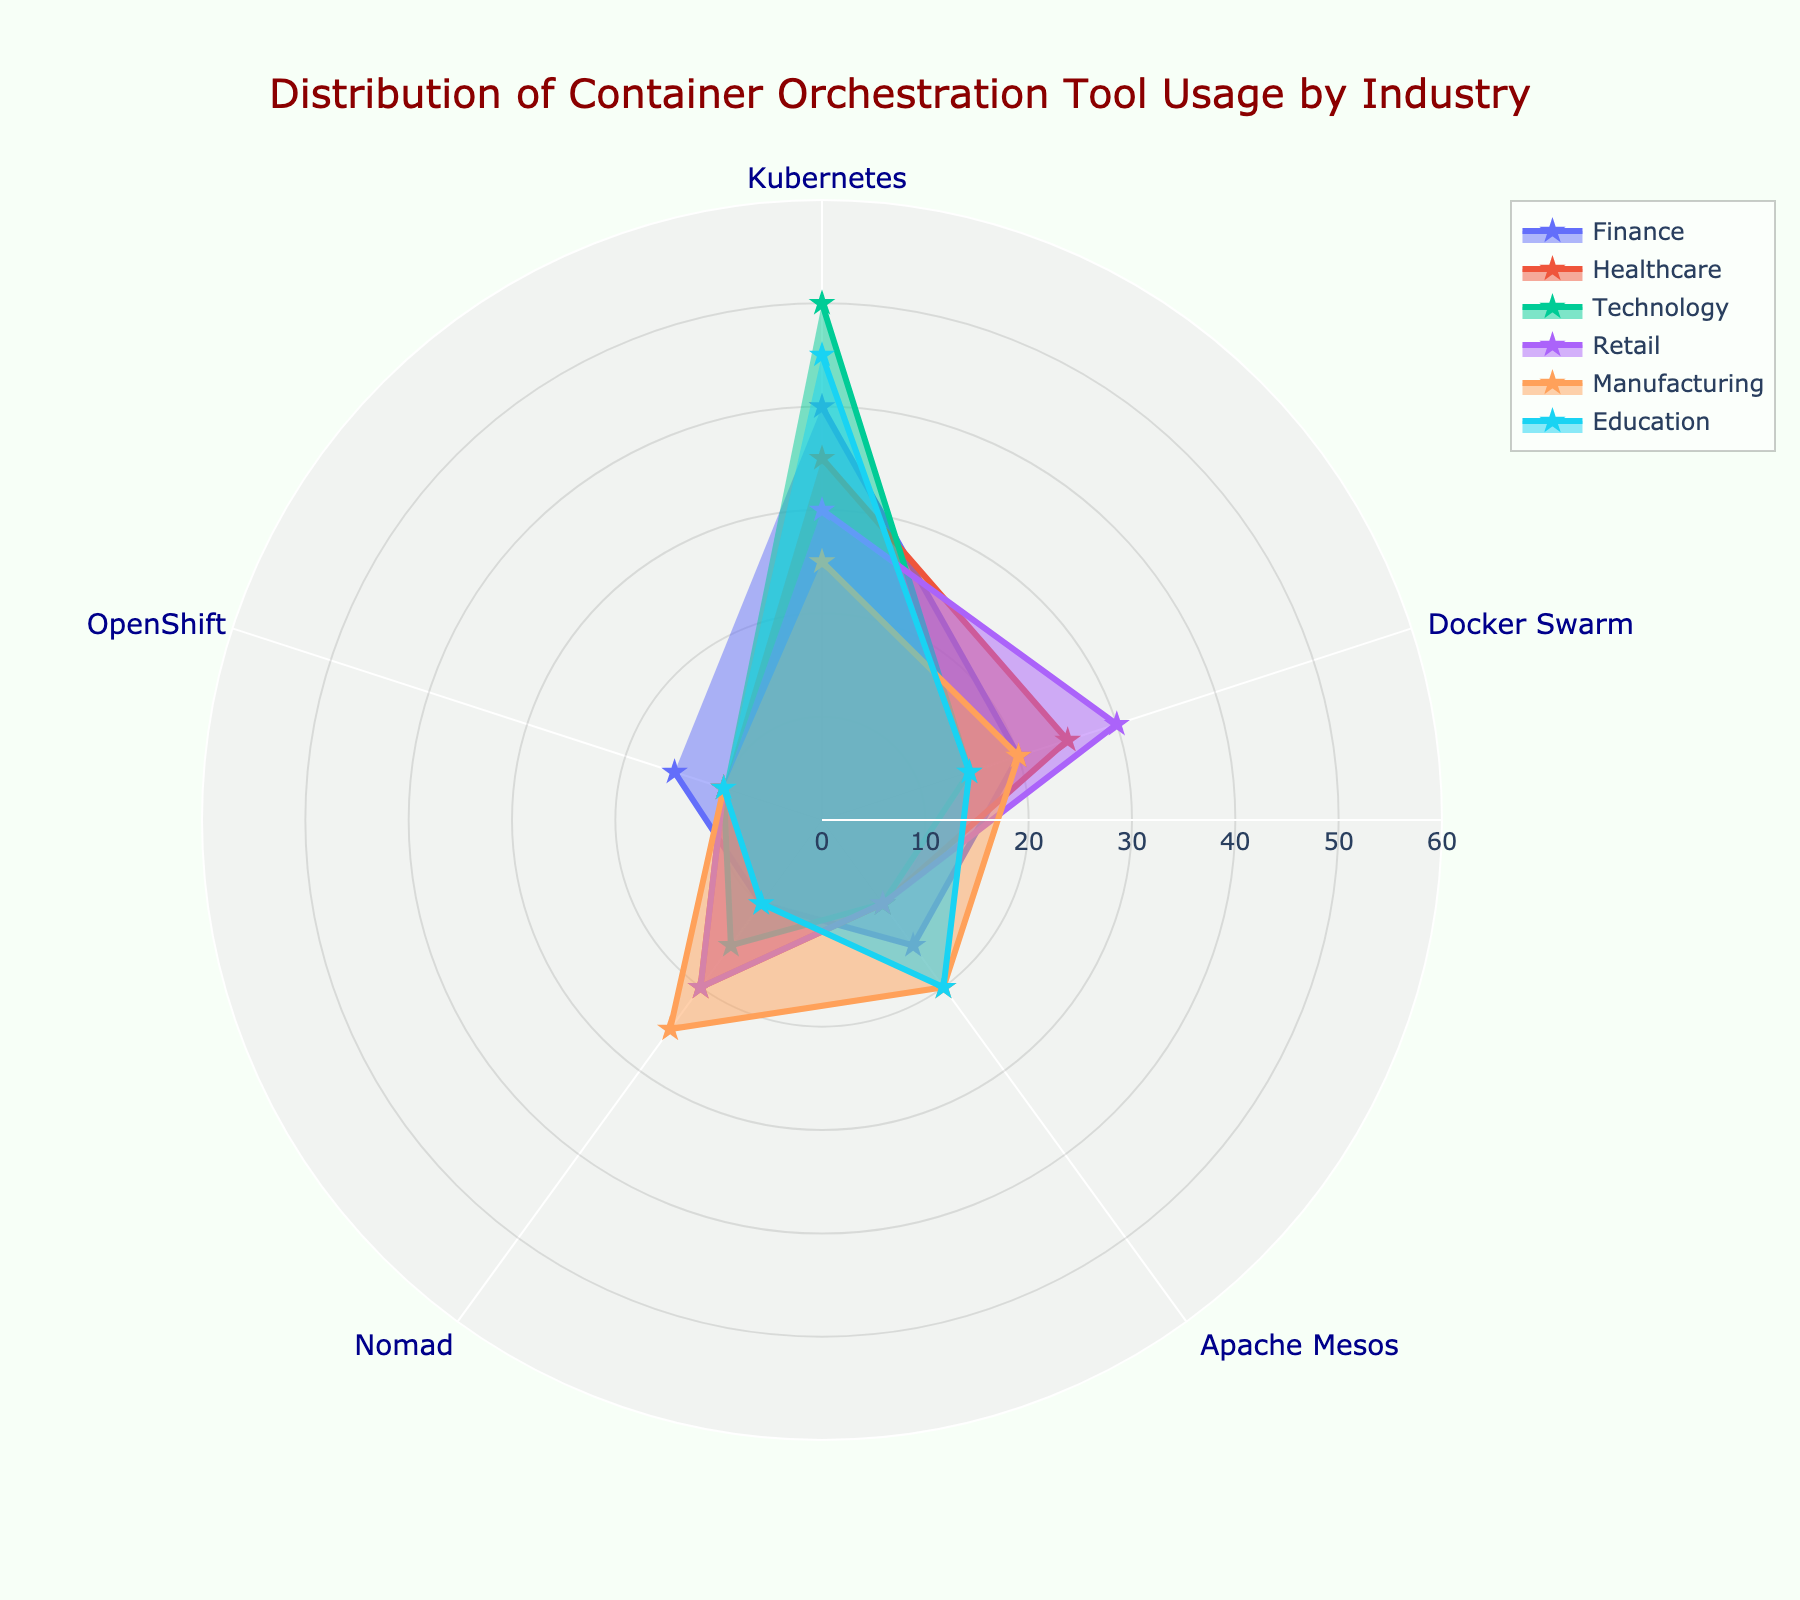Which industry uses Kubernetes the most? To determine which industry uses Kubernetes the most, look at the data points on the chart where each industry has a marker at the Kubernetes position. The value for Technology is the highest with 50.
Answer: Technology Which orchestration tool is least used in Healthcare? Identify the lowest value in the Healthcare sector. The value for OpenShift is the lowest with 10.
Answer: OpenShift How does the use of Docker Swarm in Manufacturing compare to Healthcare? Compare the data points of Docker Swarm usage for Manufacturing and Healthcare. Manufacturing has 20, while Healthcare has 25, so Healthcare uses it more.
Answer: Healthcare What is the average usage of Apache Mesos across all industries? Sum the usage values of Apache Mesos across all industries and divide by the number of industries: (15 + 10 + 10 + 10 + 20 + 20)/6 = 85/6 ≈ 14.17
Answer: 14.17 Which industry shows the highest variance in tool usage? Identify the industry with the widest range between the highest and lowest usage values. Finance ranges from 10 to 40, Healthcare from 10 to 35, Technology from 10 to 50, Retail from 10 to 30, Manufacturing from 10 to 25, and Education from 10 to 45. Technology has the highest variance.
Answer: Technology What is the combined usage of Nomad in Finance and Retail? Add the usage values of Nomad in Finance and Retail: 10 (Finance) + 20 (Retail) = 30.
Answer: 30 How does the usage of OpenShift in Finance compare to Education? Compare the OpenShift data points for Finance and Education. Finance has 15, while Education has 10, so Finance uses it more.
Answer: Finance Which industry relies equally on Apache Mesos and Nomad? Check the values for Apache Mesos and Nomad for each industry. Manufacturing has equal values for Apache Mesos and Nomad, both at 20.
Answer: Manufacturing What is the median value of Kubernetes usage across all industries? Organize the values of Kubernetes usage in ascending order: 25, 30, 35, 40, 45, 50. The median is the average of the third and fourth values: (35 + 40)/2 = 37.5.
Answer: 37.5 